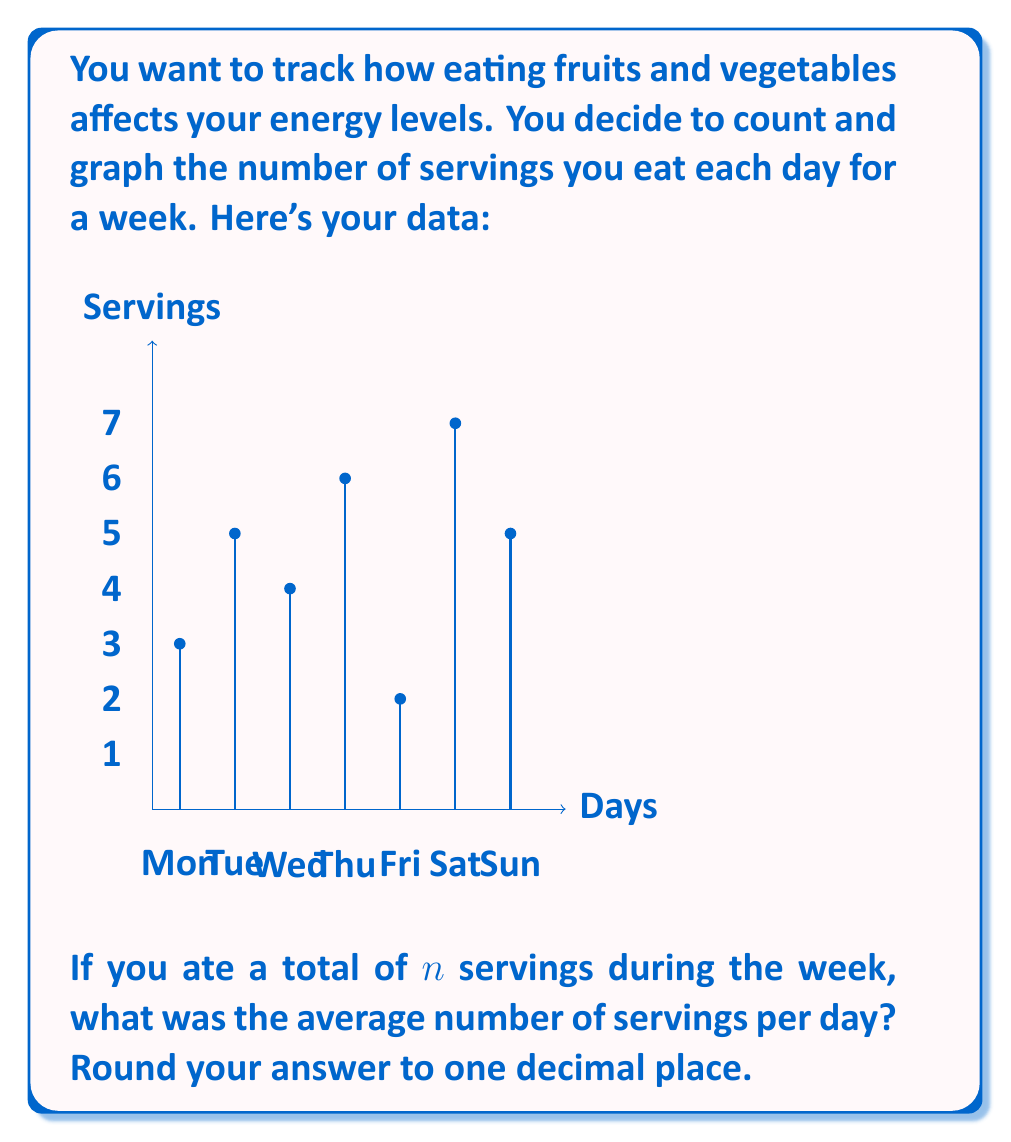Provide a solution to this math problem. Let's approach this step-by-step:

1) First, we need to find the total number of servings ($n$) for the week. We can do this by adding up the servings for each day:

   $n = 3 + 5 + 4 + 6 + 2 + 7 + 5 = 32$ servings

2) To find the average, we divide the total number of servings by the number of days:

   Average = $\frac{\text{Total servings}}{\text{Number of days}} = \frac{n}{7}$

3) Substituting our value for $n$:

   Average = $\frac{32}{7} = 4.5714...$

4) Rounding to one decimal place:

   Average ≈ 4.6 servings per day
Answer: 4.6 servings/day 